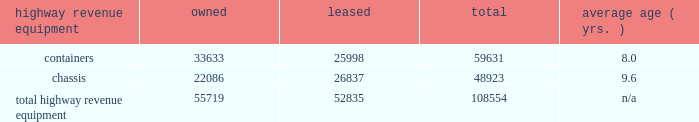Average highway revenue equipment owned leased total age ( yrs. ) .
Capital expenditures our rail network requires significant annual capital investments for replacement , improvement , and expansion .
These investments enhance safety , support the transportation needs of our customers , and improve our operational efficiency .
Additionally , we add new locomotives and freight cars to our fleet to replace older , less efficient equipment , to support growth and customer demand , and to reduce our impact on the environment through the acquisition of more fuel-efficient and low-emission locomotives .
2015 capital program 2013 during 2015 , our capital program totaled $ 4.3 billion .
( see the cash capital expenditures table in management 2019s discussion and analysis of financial condition and results of operations 2013 liquidity and capital resources , item 7. ) 2016 capital plan 2013 in 2016 , we expect our capital plan to be approximately $ 3.75 billion , which will include expenditures for ptc of approximately $ 375 million and may include non-cash investments .
We may revise our 2016 capital plan if business conditions warrant or if new laws or regulations affect our ability to generate sufficient returns on these investments .
( see discussion of our 2016 capital plan in management 2019s discussion and analysis of financial condition and results of operations 2013 2016 outlook , item 7. ) equipment encumbrances 2013 equipment with a carrying value of approximately $ 2.6 billion and $ 2.8 billion at december 31 , 2015 , and 2014 , respectively served as collateral for capital leases and other types of equipment obligations in accordance with the secured financing arrangements utilized to acquire or refinance such railroad equipment .
As a result of the merger of missouri pacific railroad company ( mprr ) with and into uprr on january 1 , 1997 , and pursuant to the underlying indentures for the mprr mortgage bonds , uprr must maintain the same value of assets after the merger in order to comply with the security requirements of the mortgage bonds .
As of the merger date , the value of the mprr assets that secured the mortgage bonds was approximately $ 6.0 billion .
In accordance with the terms of the indentures , this collateral value must be maintained during the entire term of the mortgage bonds irrespective of the outstanding balance of such bonds .
Environmental matters 2013 certain of our properties are subject to federal , state , and local laws and regulations governing the protection of the environment .
( see discussion of environmental issues in business 2013 governmental and environmental regulation , item 1 , and management 2019s discussion and analysis of financial condition and results of operations 2013 critical accounting policies 2013 environmental , item 7. ) item 3 .
Legal proceedings from time to time , we are involved in legal proceedings , claims , and litigation that occur in connection with our business .
We routinely assess our liabilities and contingencies in connection with these matters based upon the latest available information and , when necessary , we seek input from our third-party advisors when making these assessments .
Consistent with sec rules and requirements , we describe below material pending legal proceedings ( other than ordinary routine litigation incidental to our business ) , material proceedings known to be contemplated by governmental authorities , other proceedings arising under federal , state , or local environmental laws and regulations ( including governmental proceedings involving potential fines , penalties , or other monetary sanctions in excess of $ 100000 ) , and such other pending matters that we may determine to be appropriate. .
What percentage of total highway revenue equipment leased is containers? 
Computations: (25998 / 52835)
Answer: 0.49206. 